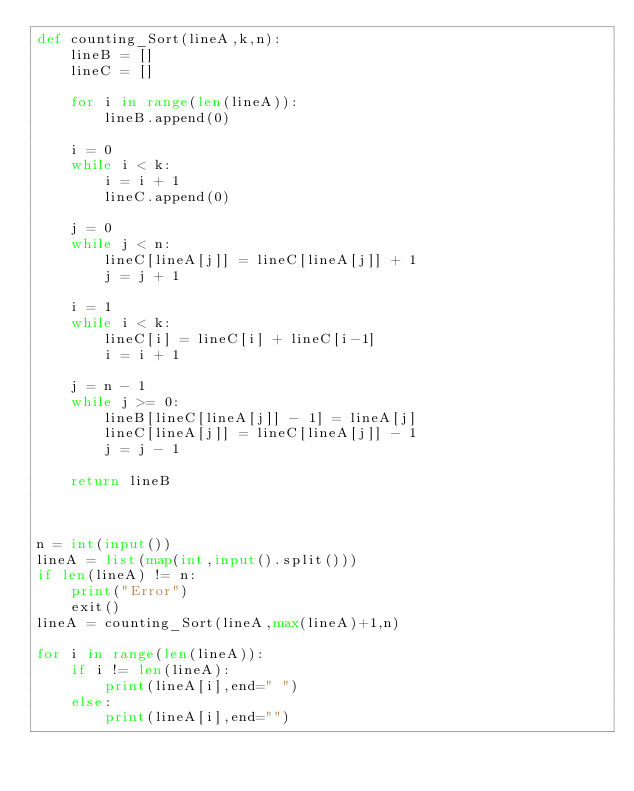Convert code to text. <code><loc_0><loc_0><loc_500><loc_500><_Python_>def counting_Sort(lineA,k,n):
    lineB = []
    lineC = []

    for i in range(len(lineA)):
        lineB.append(0)

    i = 0
    while i < k:
        i = i + 1
        lineC.append(0)

    j = 0
    while j < n:
        lineC[lineA[j]] = lineC[lineA[j]] + 1
        j = j + 1

    i = 1
    while i < k:
        lineC[i] = lineC[i] + lineC[i-1]
        i = i + 1

    j = n - 1
    while j >= 0:
        lineB[lineC[lineA[j]] - 1] = lineA[j]
        lineC[lineA[j]] = lineC[lineA[j]] - 1
        j = j - 1

    return lineB



n = int(input())
lineA = list(map(int,input().split()))
if len(lineA) != n:
    print("Error")
    exit()
lineA = counting_Sort(lineA,max(lineA)+1,n)

for i in range(len(lineA)):
    if i != len(lineA):
        print(lineA[i],end=" ")
    else:
        print(lineA[i],end="")

</code> 